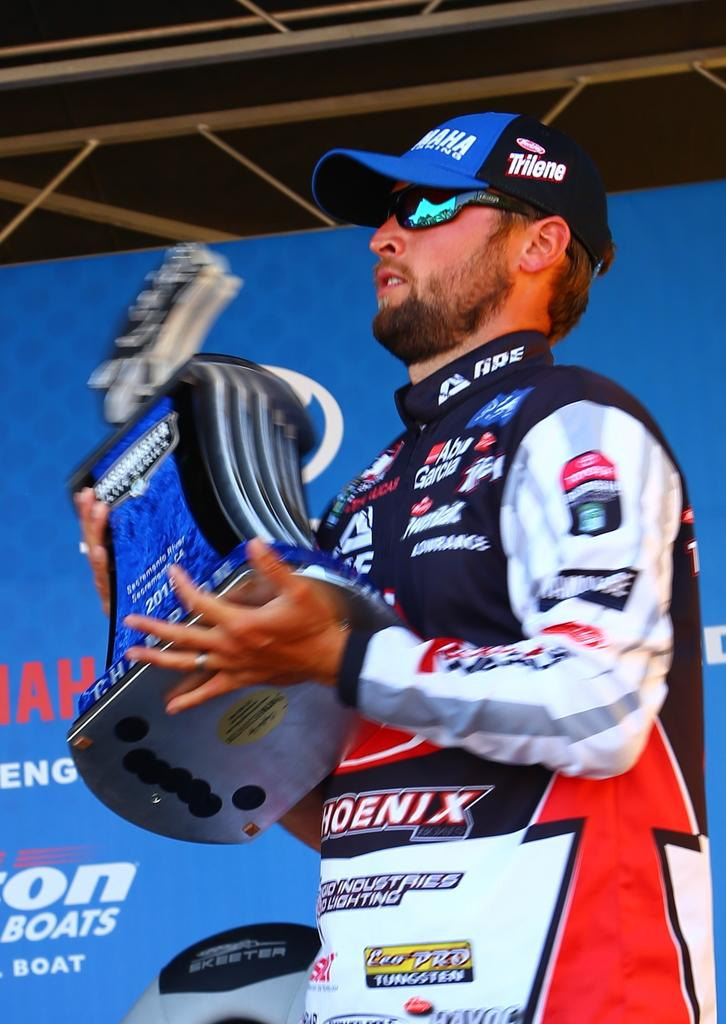What is the man in the image doing? The man is standing in the image. What is the man holding in the image? The man is holding an object. What can be seen in the background of the image? There is a hoarding in the hoarding in the background of the image. What is written on the hoarding? There is text on the hoarding. What structures are visible at the top of the image? There are rods visible at the top of the image. How many minutes does it take for the man's arm to grow in the image? The man's arm does not grow in the image, and there is no indication of time passing. 